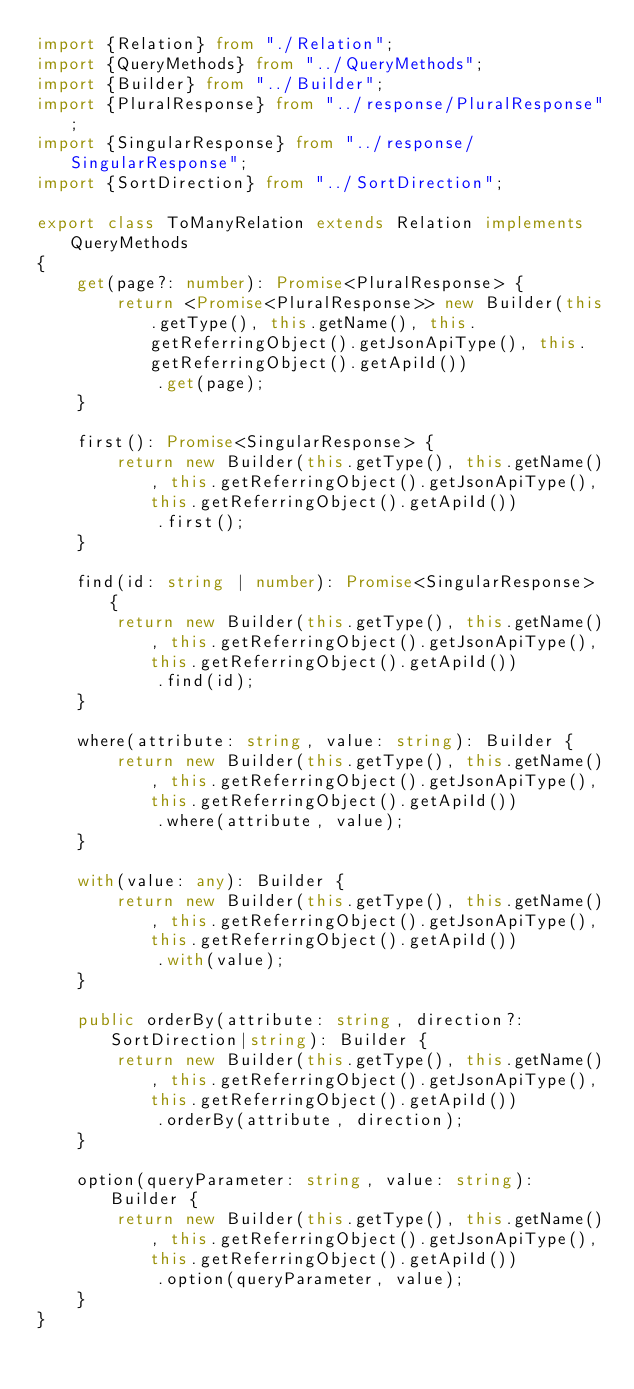<code> <loc_0><loc_0><loc_500><loc_500><_TypeScript_>import {Relation} from "./Relation";
import {QueryMethods} from "../QueryMethods";
import {Builder} from "../Builder";
import {PluralResponse} from "../response/PluralResponse";
import {SingularResponse} from "../response/SingularResponse";
import {SortDirection} from "../SortDirection";

export class ToManyRelation extends Relation implements QueryMethods
{
    get(page?: number): Promise<PluralResponse> {
        return <Promise<PluralResponse>> new Builder(this.getType(), this.getName(), this.getReferringObject().getJsonApiType(), this.getReferringObject().getApiId())
            .get(page);
    }

    first(): Promise<SingularResponse> {
        return new Builder(this.getType(), this.getName(), this.getReferringObject().getJsonApiType(), this.getReferringObject().getApiId())
            .first();
    }

    find(id: string | number): Promise<SingularResponse> {
        return new Builder(this.getType(), this.getName(), this.getReferringObject().getJsonApiType(), this.getReferringObject().getApiId())
            .find(id);
    }

    where(attribute: string, value: string): Builder {
        return new Builder(this.getType(), this.getName(), this.getReferringObject().getJsonApiType(), this.getReferringObject().getApiId())
            .where(attribute, value);
    }

    with(value: any): Builder {
        return new Builder(this.getType(), this.getName(), this.getReferringObject().getJsonApiType(), this.getReferringObject().getApiId())
            .with(value);
    }

    public orderBy(attribute: string, direction?: SortDirection|string): Builder {
        return new Builder(this.getType(), this.getName(), this.getReferringObject().getJsonApiType(), this.getReferringObject().getApiId())
            .orderBy(attribute, direction);
    }

    option(queryParameter: string, value: string): Builder {
        return new Builder(this.getType(), this.getName(), this.getReferringObject().getJsonApiType(), this.getReferringObject().getApiId())
            .option(queryParameter, value);
    }
}
</code> 